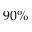<formula> <loc_0><loc_0><loc_500><loc_500>9 0 \%</formula> 